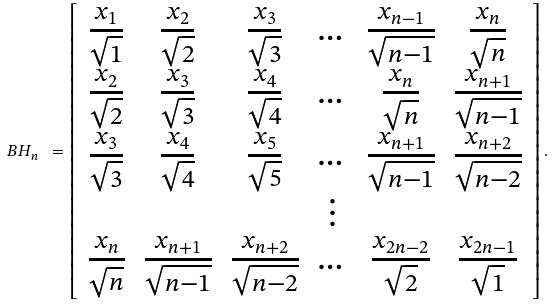<formula> <loc_0><loc_0><loc_500><loc_500>B H _ { n } \ = \left [ \begin{array} { c c c c c c } \frac { x _ { 1 } } { \sqrt { 1 } } & \frac { x _ { 2 } } { \sqrt { 2 } } & \frac { x _ { 3 } } { \sqrt { 3 } } & \dots & \frac { x _ { n - 1 } } { \sqrt { n - 1 } } & \frac { x _ { n } } { \sqrt { n } } \\ \frac { x _ { 2 } } { \sqrt { 2 } } & \frac { x _ { 3 } } { \sqrt { 3 } } & \frac { x _ { 4 } } { \sqrt { 4 } } & \dots & \frac { x _ { n } } { \sqrt { n } } & \frac { x _ { n + 1 } } { \sqrt { n - 1 } } \\ \frac { x _ { 3 } } { \sqrt { 3 } } & \frac { x _ { 4 } } { \sqrt { 4 } } & \frac { x _ { 5 } } { \sqrt { 5 } } & \dots & \frac { x _ { n + 1 } } { \sqrt { n - 1 } } & \frac { x _ { n + 2 } } { \sqrt { n - 2 } } \\ & & & \vdots & & \\ \frac { x _ { n } } { \sqrt { n } } & \frac { x _ { n + 1 } } { \sqrt { n - 1 } } & \frac { x _ { n + 2 } } { \sqrt { n - 2 } } & \dots & \frac { x _ { 2 n - 2 } } { \sqrt { 2 } } & \frac { x _ { 2 n - 1 } } { \sqrt { 1 } } \end{array} \right ] .</formula> 